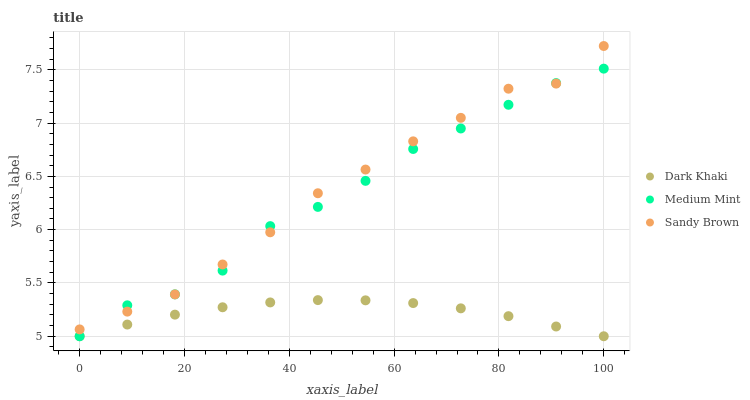Does Dark Khaki have the minimum area under the curve?
Answer yes or no. Yes. Does Sandy Brown have the maximum area under the curve?
Answer yes or no. Yes. Does Medium Mint have the minimum area under the curve?
Answer yes or no. No. Does Medium Mint have the maximum area under the curve?
Answer yes or no. No. Is Dark Khaki the smoothest?
Answer yes or no. Yes. Is Medium Mint the roughest?
Answer yes or no. Yes. Is Sandy Brown the smoothest?
Answer yes or no. No. Is Sandy Brown the roughest?
Answer yes or no. No. Does Dark Khaki have the lowest value?
Answer yes or no. Yes. Does Sandy Brown have the lowest value?
Answer yes or no. No. Does Sandy Brown have the highest value?
Answer yes or no. Yes. Does Medium Mint have the highest value?
Answer yes or no. No. Is Dark Khaki less than Sandy Brown?
Answer yes or no. Yes. Is Sandy Brown greater than Dark Khaki?
Answer yes or no. Yes. Does Dark Khaki intersect Medium Mint?
Answer yes or no. Yes. Is Dark Khaki less than Medium Mint?
Answer yes or no. No. Is Dark Khaki greater than Medium Mint?
Answer yes or no. No. Does Dark Khaki intersect Sandy Brown?
Answer yes or no. No. 